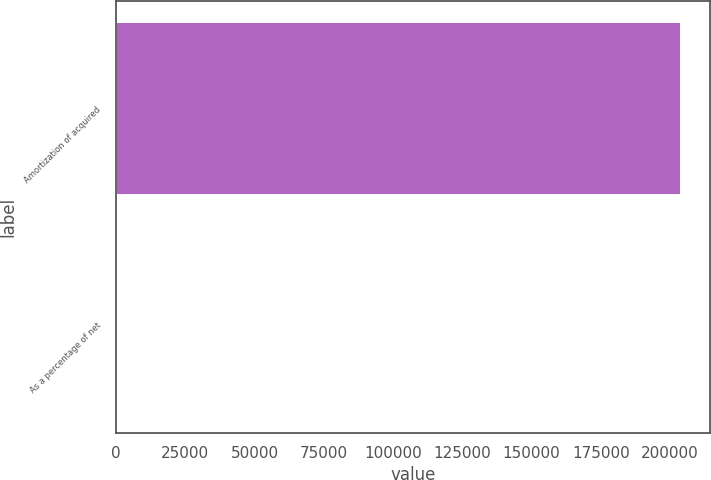<chart> <loc_0><loc_0><loc_500><loc_500><bar_chart><fcel>Amortization of acquired<fcel>As a percentage of net<nl><fcel>204104<fcel>2.7<nl></chart> 